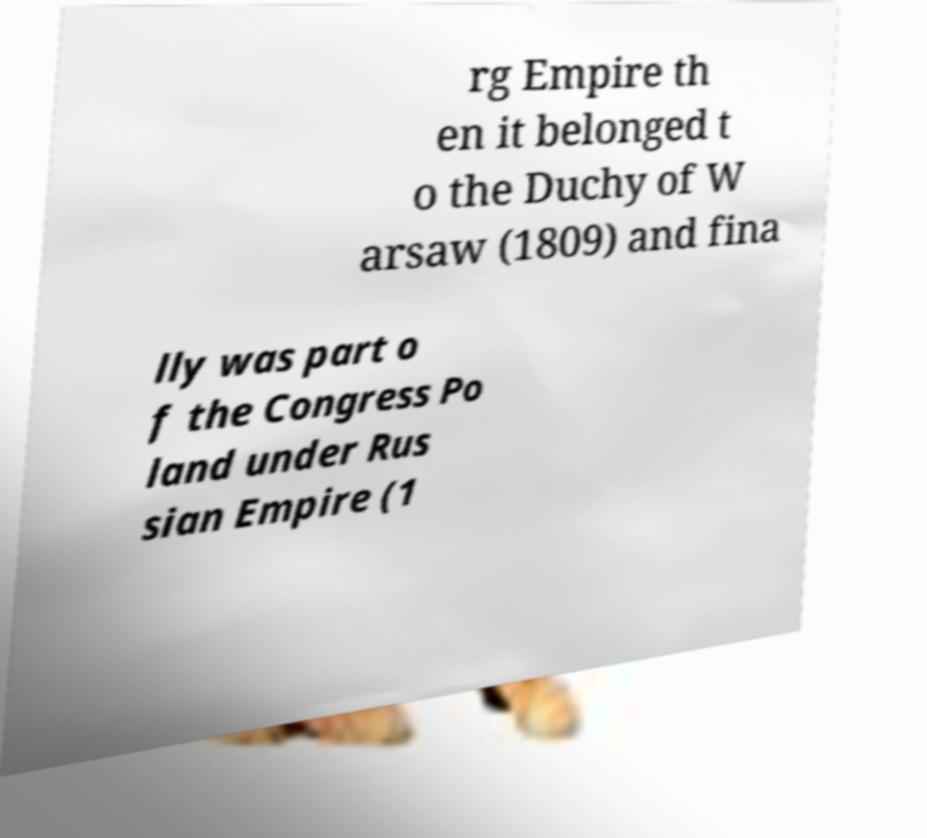Please identify and transcribe the text found in this image. rg Empire th en it belonged t o the Duchy of W arsaw (1809) and fina lly was part o f the Congress Po land under Rus sian Empire (1 